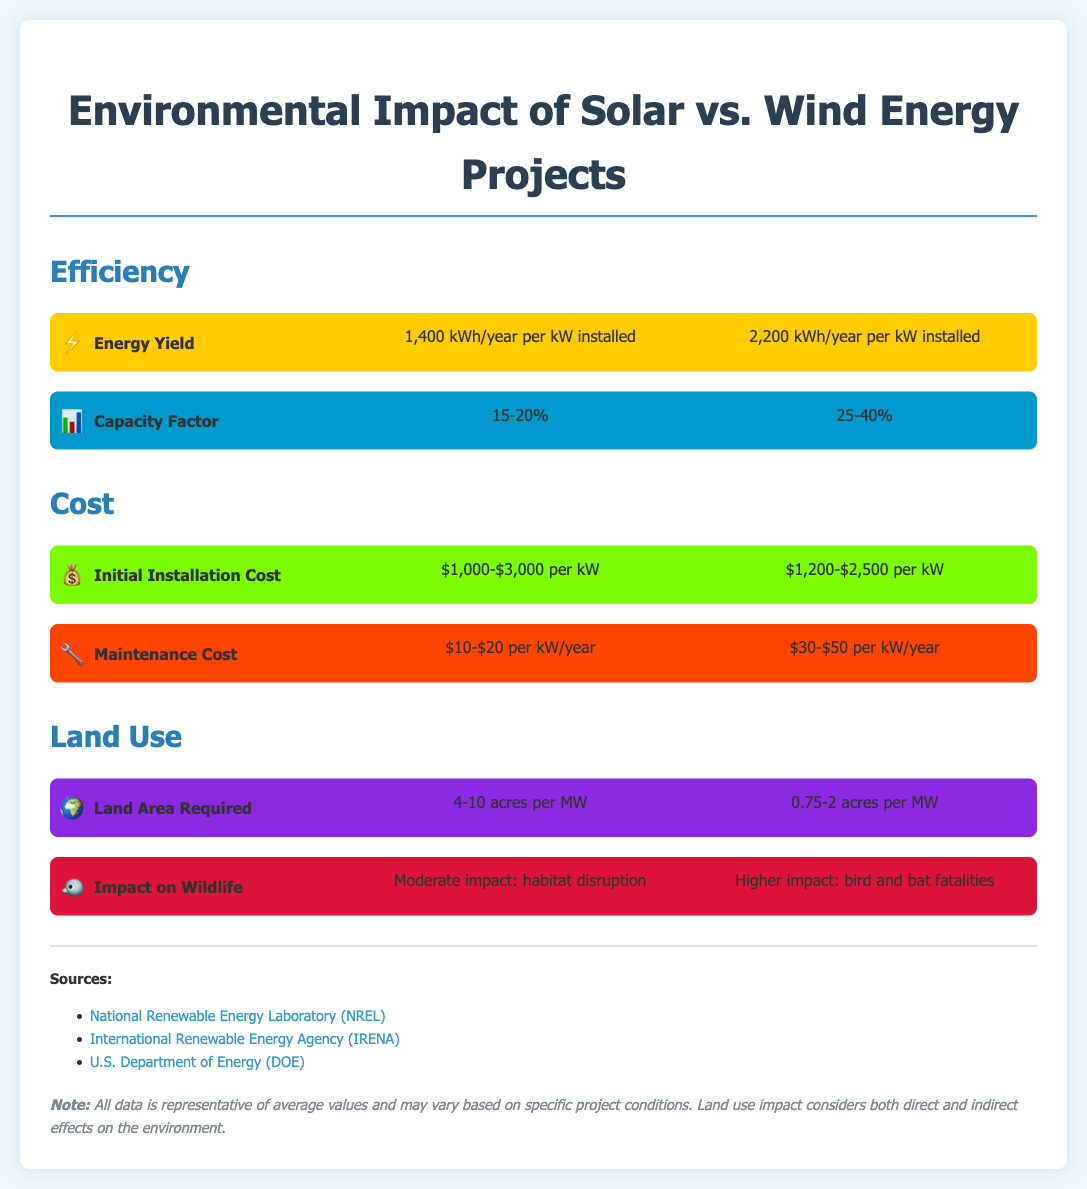What is the energy yield for solar energy? The document states that solar energy has an energy yield of 1,400 kWh/year per kW installed.
Answer: 1,400 kWh/year per kW installed What is the capacity factor range for wind energy? The capacity factor for wind energy is provided in the document as 25-40%.
Answer: 25-40% What is the initial installation cost for solar energy? According to the document, the initial installation cost for solar energy ranges from $1,000 to $3,000 per kW.
Answer: $1,000-$3,000 per kW Which energy source has a higher maintenance cost? The document indicates that wind energy has a higher maintenance cost compared to solar energy.
Answer: Wind How much land area is required for wind energy projects? The document specifies that wind energy requires 0.75-2 acres per MW.
Answer: 0.75-2 acres per MW What impact on wildlife is associated with solar energy? The document mentions that solar energy has a moderate impact on wildlife due to habitat disruption.
Answer: Moderate impact: habitat disruption Which energy type has a lower land area requirement? The comparison in the document shows that wind energy has a lower land area requirement compared to solar energy.
Answer: Wind What is the primary source cited for the data in this infographic? The document lists the National Renewable Energy Laboratory (NREL) as one of the sources of data.
Answer: National Renewable Energy Laboratory (NREL) 